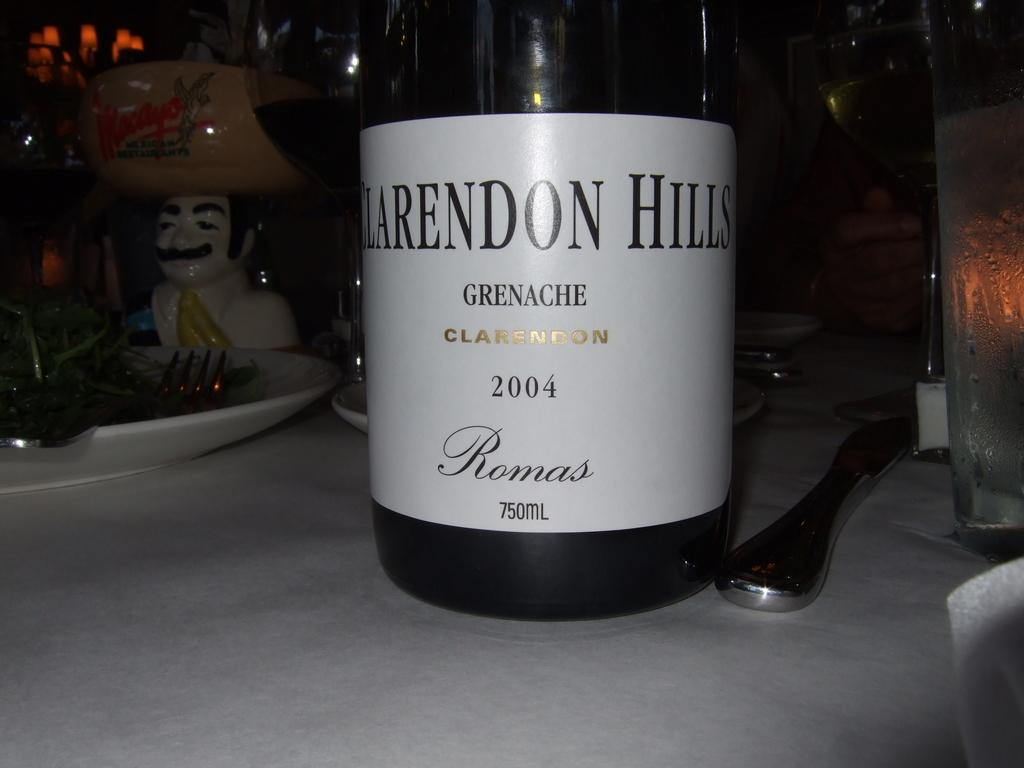<image>
Present a compact description of the photo's key features. A Bottle of Clarendon Hills from Romas brand tagged year 2004 on a table. 